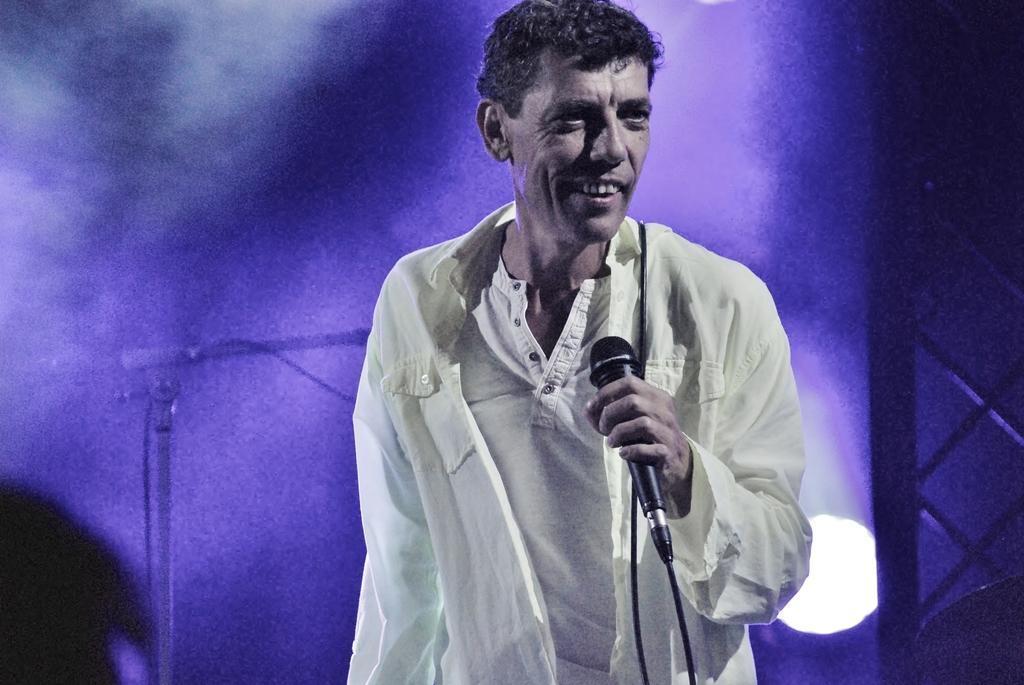What is present in the image? There is a man in the image. What is the man doing in the image? The man is standing in the image. What object is the man holding in his hand? The man is holding a microphone in his hand. What type of bird is sitting in the man's pocket in the image? There is no bird, specifically a crow, present in the image, nor is there any indication of a bird sitting in the man's pocket. 